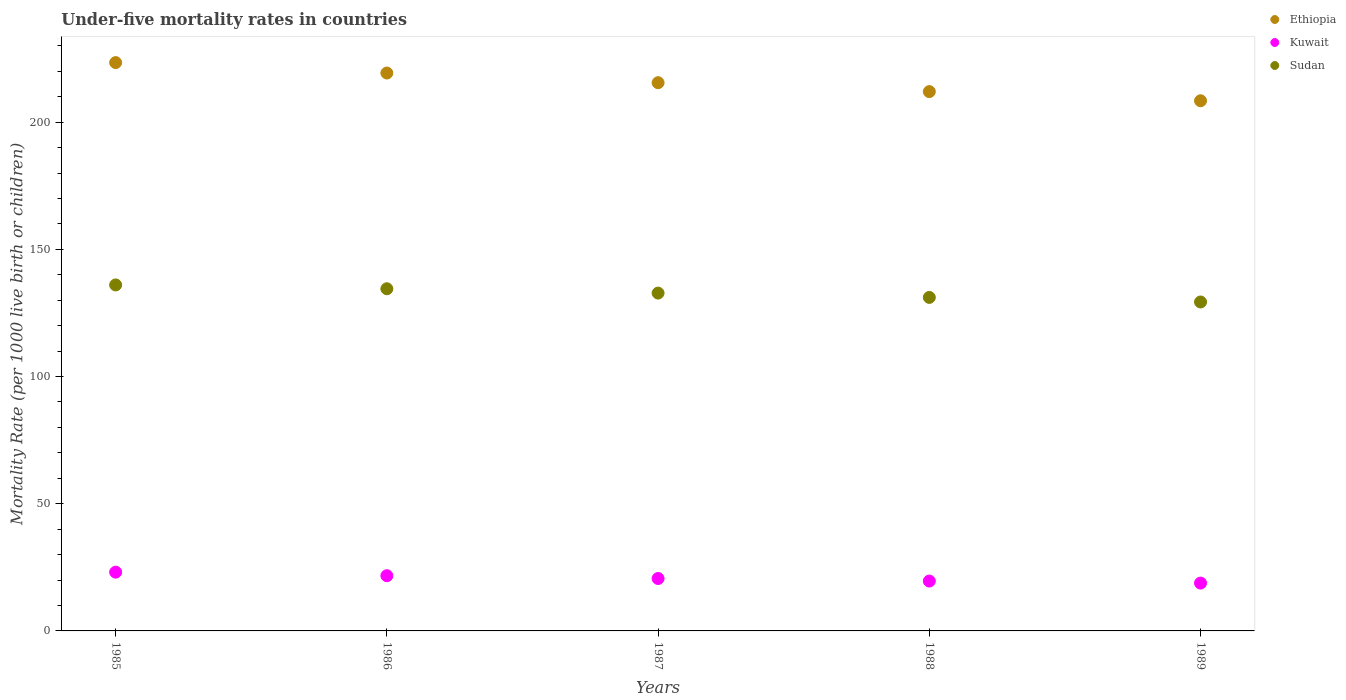Is the number of dotlines equal to the number of legend labels?
Give a very brief answer. Yes. What is the under-five mortality rate in Sudan in 1986?
Keep it short and to the point. 134.5. Across all years, what is the maximum under-five mortality rate in Sudan?
Offer a very short reply. 136. Across all years, what is the minimum under-five mortality rate in Sudan?
Your response must be concise. 129.3. What is the total under-five mortality rate in Kuwait in the graph?
Provide a succinct answer. 103.8. What is the difference between the under-five mortality rate in Ethiopia in 1985 and that in 1986?
Give a very brief answer. 4.1. What is the difference between the under-five mortality rate in Sudan in 1988 and the under-five mortality rate in Kuwait in 1989?
Provide a short and direct response. 112.3. What is the average under-five mortality rate in Kuwait per year?
Your answer should be very brief. 20.76. In the year 1985, what is the difference between the under-five mortality rate in Sudan and under-five mortality rate in Ethiopia?
Ensure brevity in your answer.  -87.4. In how many years, is the under-five mortality rate in Sudan greater than 50?
Give a very brief answer. 5. What is the ratio of the under-five mortality rate in Ethiopia in 1985 to that in 1986?
Your answer should be very brief. 1.02. What is the difference between the highest and the second highest under-five mortality rate in Kuwait?
Ensure brevity in your answer.  1.4. What is the difference between the highest and the lowest under-five mortality rate in Kuwait?
Provide a succinct answer. 4.3. Is it the case that in every year, the sum of the under-five mortality rate in Ethiopia and under-five mortality rate in Kuwait  is greater than the under-five mortality rate in Sudan?
Make the answer very short. Yes. How many years are there in the graph?
Make the answer very short. 5. What is the difference between two consecutive major ticks on the Y-axis?
Provide a succinct answer. 50. Does the graph contain any zero values?
Provide a short and direct response. No. How many legend labels are there?
Offer a terse response. 3. What is the title of the graph?
Give a very brief answer. Under-five mortality rates in countries. Does "Vietnam" appear as one of the legend labels in the graph?
Keep it short and to the point. No. What is the label or title of the X-axis?
Your response must be concise. Years. What is the label or title of the Y-axis?
Provide a short and direct response. Mortality Rate (per 1000 live birth or children). What is the Mortality Rate (per 1000 live birth or children) in Ethiopia in 1985?
Offer a very short reply. 223.4. What is the Mortality Rate (per 1000 live birth or children) of Kuwait in 1985?
Offer a very short reply. 23.1. What is the Mortality Rate (per 1000 live birth or children) in Sudan in 1985?
Your response must be concise. 136. What is the Mortality Rate (per 1000 live birth or children) in Ethiopia in 1986?
Offer a very short reply. 219.3. What is the Mortality Rate (per 1000 live birth or children) of Kuwait in 1986?
Your response must be concise. 21.7. What is the Mortality Rate (per 1000 live birth or children) in Sudan in 1986?
Provide a succinct answer. 134.5. What is the Mortality Rate (per 1000 live birth or children) of Ethiopia in 1987?
Your answer should be compact. 215.5. What is the Mortality Rate (per 1000 live birth or children) of Kuwait in 1987?
Your answer should be very brief. 20.6. What is the Mortality Rate (per 1000 live birth or children) of Sudan in 1987?
Provide a short and direct response. 132.8. What is the Mortality Rate (per 1000 live birth or children) in Ethiopia in 1988?
Provide a succinct answer. 212. What is the Mortality Rate (per 1000 live birth or children) in Kuwait in 1988?
Make the answer very short. 19.6. What is the Mortality Rate (per 1000 live birth or children) of Sudan in 1988?
Offer a very short reply. 131.1. What is the Mortality Rate (per 1000 live birth or children) of Ethiopia in 1989?
Your answer should be very brief. 208.4. What is the Mortality Rate (per 1000 live birth or children) of Sudan in 1989?
Give a very brief answer. 129.3. Across all years, what is the maximum Mortality Rate (per 1000 live birth or children) of Ethiopia?
Provide a short and direct response. 223.4. Across all years, what is the maximum Mortality Rate (per 1000 live birth or children) of Kuwait?
Make the answer very short. 23.1. Across all years, what is the maximum Mortality Rate (per 1000 live birth or children) in Sudan?
Offer a very short reply. 136. Across all years, what is the minimum Mortality Rate (per 1000 live birth or children) in Ethiopia?
Give a very brief answer. 208.4. Across all years, what is the minimum Mortality Rate (per 1000 live birth or children) in Sudan?
Provide a short and direct response. 129.3. What is the total Mortality Rate (per 1000 live birth or children) in Ethiopia in the graph?
Your answer should be very brief. 1078.6. What is the total Mortality Rate (per 1000 live birth or children) of Kuwait in the graph?
Offer a very short reply. 103.8. What is the total Mortality Rate (per 1000 live birth or children) of Sudan in the graph?
Your answer should be very brief. 663.7. What is the difference between the Mortality Rate (per 1000 live birth or children) of Ethiopia in 1985 and that in 1986?
Give a very brief answer. 4.1. What is the difference between the Mortality Rate (per 1000 live birth or children) of Kuwait in 1985 and that in 1986?
Give a very brief answer. 1.4. What is the difference between the Mortality Rate (per 1000 live birth or children) in Sudan in 1985 and that in 1986?
Offer a very short reply. 1.5. What is the difference between the Mortality Rate (per 1000 live birth or children) in Ethiopia in 1985 and that in 1987?
Ensure brevity in your answer.  7.9. What is the difference between the Mortality Rate (per 1000 live birth or children) of Sudan in 1985 and that in 1987?
Offer a very short reply. 3.2. What is the difference between the Mortality Rate (per 1000 live birth or children) in Ethiopia in 1985 and that in 1988?
Keep it short and to the point. 11.4. What is the difference between the Mortality Rate (per 1000 live birth or children) of Sudan in 1985 and that in 1988?
Provide a short and direct response. 4.9. What is the difference between the Mortality Rate (per 1000 live birth or children) of Kuwait in 1985 and that in 1989?
Provide a short and direct response. 4.3. What is the difference between the Mortality Rate (per 1000 live birth or children) of Kuwait in 1986 and that in 1987?
Ensure brevity in your answer.  1.1. What is the difference between the Mortality Rate (per 1000 live birth or children) of Sudan in 1986 and that in 1987?
Make the answer very short. 1.7. What is the difference between the Mortality Rate (per 1000 live birth or children) in Sudan in 1986 and that in 1988?
Ensure brevity in your answer.  3.4. What is the difference between the Mortality Rate (per 1000 live birth or children) of Ethiopia in 1986 and that in 1989?
Offer a terse response. 10.9. What is the difference between the Mortality Rate (per 1000 live birth or children) of Kuwait in 1986 and that in 1989?
Give a very brief answer. 2.9. What is the difference between the Mortality Rate (per 1000 live birth or children) of Kuwait in 1987 and that in 1988?
Provide a succinct answer. 1. What is the difference between the Mortality Rate (per 1000 live birth or children) in Ethiopia in 1987 and that in 1989?
Keep it short and to the point. 7.1. What is the difference between the Mortality Rate (per 1000 live birth or children) of Sudan in 1987 and that in 1989?
Your answer should be very brief. 3.5. What is the difference between the Mortality Rate (per 1000 live birth or children) in Ethiopia in 1988 and that in 1989?
Your response must be concise. 3.6. What is the difference between the Mortality Rate (per 1000 live birth or children) of Kuwait in 1988 and that in 1989?
Offer a terse response. 0.8. What is the difference between the Mortality Rate (per 1000 live birth or children) in Sudan in 1988 and that in 1989?
Give a very brief answer. 1.8. What is the difference between the Mortality Rate (per 1000 live birth or children) in Ethiopia in 1985 and the Mortality Rate (per 1000 live birth or children) in Kuwait in 1986?
Ensure brevity in your answer.  201.7. What is the difference between the Mortality Rate (per 1000 live birth or children) of Ethiopia in 1985 and the Mortality Rate (per 1000 live birth or children) of Sudan in 1986?
Ensure brevity in your answer.  88.9. What is the difference between the Mortality Rate (per 1000 live birth or children) in Kuwait in 1985 and the Mortality Rate (per 1000 live birth or children) in Sudan in 1986?
Provide a succinct answer. -111.4. What is the difference between the Mortality Rate (per 1000 live birth or children) in Ethiopia in 1985 and the Mortality Rate (per 1000 live birth or children) in Kuwait in 1987?
Ensure brevity in your answer.  202.8. What is the difference between the Mortality Rate (per 1000 live birth or children) of Ethiopia in 1985 and the Mortality Rate (per 1000 live birth or children) of Sudan in 1987?
Your answer should be compact. 90.6. What is the difference between the Mortality Rate (per 1000 live birth or children) in Kuwait in 1985 and the Mortality Rate (per 1000 live birth or children) in Sudan in 1987?
Keep it short and to the point. -109.7. What is the difference between the Mortality Rate (per 1000 live birth or children) of Ethiopia in 1985 and the Mortality Rate (per 1000 live birth or children) of Kuwait in 1988?
Make the answer very short. 203.8. What is the difference between the Mortality Rate (per 1000 live birth or children) of Ethiopia in 1985 and the Mortality Rate (per 1000 live birth or children) of Sudan in 1988?
Provide a short and direct response. 92.3. What is the difference between the Mortality Rate (per 1000 live birth or children) in Kuwait in 1985 and the Mortality Rate (per 1000 live birth or children) in Sudan in 1988?
Your response must be concise. -108. What is the difference between the Mortality Rate (per 1000 live birth or children) in Ethiopia in 1985 and the Mortality Rate (per 1000 live birth or children) in Kuwait in 1989?
Make the answer very short. 204.6. What is the difference between the Mortality Rate (per 1000 live birth or children) of Ethiopia in 1985 and the Mortality Rate (per 1000 live birth or children) of Sudan in 1989?
Ensure brevity in your answer.  94.1. What is the difference between the Mortality Rate (per 1000 live birth or children) in Kuwait in 1985 and the Mortality Rate (per 1000 live birth or children) in Sudan in 1989?
Make the answer very short. -106.2. What is the difference between the Mortality Rate (per 1000 live birth or children) of Ethiopia in 1986 and the Mortality Rate (per 1000 live birth or children) of Kuwait in 1987?
Make the answer very short. 198.7. What is the difference between the Mortality Rate (per 1000 live birth or children) in Ethiopia in 1986 and the Mortality Rate (per 1000 live birth or children) in Sudan in 1987?
Offer a very short reply. 86.5. What is the difference between the Mortality Rate (per 1000 live birth or children) in Kuwait in 1986 and the Mortality Rate (per 1000 live birth or children) in Sudan in 1987?
Your answer should be very brief. -111.1. What is the difference between the Mortality Rate (per 1000 live birth or children) of Ethiopia in 1986 and the Mortality Rate (per 1000 live birth or children) of Kuwait in 1988?
Keep it short and to the point. 199.7. What is the difference between the Mortality Rate (per 1000 live birth or children) of Ethiopia in 1986 and the Mortality Rate (per 1000 live birth or children) of Sudan in 1988?
Provide a short and direct response. 88.2. What is the difference between the Mortality Rate (per 1000 live birth or children) in Kuwait in 1986 and the Mortality Rate (per 1000 live birth or children) in Sudan in 1988?
Provide a short and direct response. -109.4. What is the difference between the Mortality Rate (per 1000 live birth or children) of Ethiopia in 1986 and the Mortality Rate (per 1000 live birth or children) of Kuwait in 1989?
Make the answer very short. 200.5. What is the difference between the Mortality Rate (per 1000 live birth or children) in Ethiopia in 1986 and the Mortality Rate (per 1000 live birth or children) in Sudan in 1989?
Your response must be concise. 90. What is the difference between the Mortality Rate (per 1000 live birth or children) of Kuwait in 1986 and the Mortality Rate (per 1000 live birth or children) of Sudan in 1989?
Your answer should be very brief. -107.6. What is the difference between the Mortality Rate (per 1000 live birth or children) in Ethiopia in 1987 and the Mortality Rate (per 1000 live birth or children) in Kuwait in 1988?
Your answer should be compact. 195.9. What is the difference between the Mortality Rate (per 1000 live birth or children) in Ethiopia in 1987 and the Mortality Rate (per 1000 live birth or children) in Sudan in 1988?
Offer a terse response. 84.4. What is the difference between the Mortality Rate (per 1000 live birth or children) in Kuwait in 1987 and the Mortality Rate (per 1000 live birth or children) in Sudan in 1988?
Ensure brevity in your answer.  -110.5. What is the difference between the Mortality Rate (per 1000 live birth or children) of Ethiopia in 1987 and the Mortality Rate (per 1000 live birth or children) of Kuwait in 1989?
Your answer should be compact. 196.7. What is the difference between the Mortality Rate (per 1000 live birth or children) in Ethiopia in 1987 and the Mortality Rate (per 1000 live birth or children) in Sudan in 1989?
Offer a very short reply. 86.2. What is the difference between the Mortality Rate (per 1000 live birth or children) of Kuwait in 1987 and the Mortality Rate (per 1000 live birth or children) of Sudan in 1989?
Offer a very short reply. -108.7. What is the difference between the Mortality Rate (per 1000 live birth or children) in Ethiopia in 1988 and the Mortality Rate (per 1000 live birth or children) in Kuwait in 1989?
Your answer should be very brief. 193.2. What is the difference between the Mortality Rate (per 1000 live birth or children) in Ethiopia in 1988 and the Mortality Rate (per 1000 live birth or children) in Sudan in 1989?
Your answer should be very brief. 82.7. What is the difference between the Mortality Rate (per 1000 live birth or children) in Kuwait in 1988 and the Mortality Rate (per 1000 live birth or children) in Sudan in 1989?
Provide a succinct answer. -109.7. What is the average Mortality Rate (per 1000 live birth or children) of Ethiopia per year?
Ensure brevity in your answer.  215.72. What is the average Mortality Rate (per 1000 live birth or children) of Kuwait per year?
Ensure brevity in your answer.  20.76. What is the average Mortality Rate (per 1000 live birth or children) in Sudan per year?
Ensure brevity in your answer.  132.74. In the year 1985, what is the difference between the Mortality Rate (per 1000 live birth or children) in Ethiopia and Mortality Rate (per 1000 live birth or children) in Kuwait?
Keep it short and to the point. 200.3. In the year 1985, what is the difference between the Mortality Rate (per 1000 live birth or children) in Ethiopia and Mortality Rate (per 1000 live birth or children) in Sudan?
Offer a terse response. 87.4. In the year 1985, what is the difference between the Mortality Rate (per 1000 live birth or children) of Kuwait and Mortality Rate (per 1000 live birth or children) of Sudan?
Offer a terse response. -112.9. In the year 1986, what is the difference between the Mortality Rate (per 1000 live birth or children) of Ethiopia and Mortality Rate (per 1000 live birth or children) of Kuwait?
Make the answer very short. 197.6. In the year 1986, what is the difference between the Mortality Rate (per 1000 live birth or children) of Ethiopia and Mortality Rate (per 1000 live birth or children) of Sudan?
Give a very brief answer. 84.8. In the year 1986, what is the difference between the Mortality Rate (per 1000 live birth or children) of Kuwait and Mortality Rate (per 1000 live birth or children) of Sudan?
Provide a succinct answer. -112.8. In the year 1987, what is the difference between the Mortality Rate (per 1000 live birth or children) of Ethiopia and Mortality Rate (per 1000 live birth or children) of Kuwait?
Offer a terse response. 194.9. In the year 1987, what is the difference between the Mortality Rate (per 1000 live birth or children) of Ethiopia and Mortality Rate (per 1000 live birth or children) of Sudan?
Provide a short and direct response. 82.7. In the year 1987, what is the difference between the Mortality Rate (per 1000 live birth or children) in Kuwait and Mortality Rate (per 1000 live birth or children) in Sudan?
Keep it short and to the point. -112.2. In the year 1988, what is the difference between the Mortality Rate (per 1000 live birth or children) of Ethiopia and Mortality Rate (per 1000 live birth or children) of Kuwait?
Give a very brief answer. 192.4. In the year 1988, what is the difference between the Mortality Rate (per 1000 live birth or children) in Ethiopia and Mortality Rate (per 1000 live birth or children) in Sudan?
Your answer should be very brief. 80.9. In the year 1988, what is the difference between the Mortality Rate (per 1000 live birth or children) of Kuwait and Mortality Rate (per 1000 live birth or children) of Sudan?
Offer a very short reply. -111.5. In the year 1989, what is the difference between the Mortality Rate (per 1000 live birth or children) in Ethiopia and Mortality Rate (per 1000 live birth or children) in Kuwait?
Make the answer very short. 189.6. In the year 1989, what is the difference between the Mortality Rate (per 1000 live birth or children) in Ethiopia and Mortality Rate (per 1000 live birth or children) in Sudan?
Provide a short and direct response. 79.1. In the year 1989, what is the difference between the Mortality Rate (per 1000 live birth or children) in Kuwait and Mortality Rate (per 1000 live birth or children) in Sudan?
Offer a very short reply. -110.5. What is the ratio of the Mortality Rate (per 1000 live birth or children) in Ethiopia in 1985 to that in 1986?
Offer a very short reply. 1.02. What is the ratio of the Mortality Rate (per 1000 live birth or children) of Kuwait in 1985 to that in 1986?
Make the answer very short. 1.06. What is the ratio of the Mortality Rate (per 1000 live birth or children) in Sudan in 1985 to that in 1986?
Make the answer very short. 1.01. What is the ratio of the Mortality Rate (per 1000 live birth or children) in Ethiopia in 1985 to that in 1987?
Offer a very short reply. 1.04. What is the ratio of the Mortality Rate (per 1000 live birth or children) in Kuwait in 1985 to that in 1987?
Make the answer very short. 1.12. What is the ratio of the Mortality Rate (per 1000 live birth or children) in Sudan in 1985 to that in 1987?
Offer a terse response. 1.02. What is the ratio of the Mortality Rate (per 1000 live birth or children) of Ethiopia in 1985 to that in 1988?
Give a very brief answer. 1.05. What is the ratio of the Mortality Rate (per 1000 live birth or children) in Kuwait in 1985 to that in 1988?
Offer a terse response. 1.18. What is the ratio of the Mortality Rate (per 1000 live birth or children) in Sudan in 1985 to that in 1988?
Give a very brief answer. 1.04. What is the ratio of the Mortality Rate (per 1000 live birth or children) in Ethiopia in 1985 to that in 1989?
Give a very brief answer. 1.07. What is the ratio of the Mortality Rate (per 1000 live birth or children) of Kuwait in 1985 to that in 1989?
Offer a very short reply. 1.23. What is the ratio of the Mortality Rate (per 1000 live birth or children) of Sudan in 1985 to that in 1989?
Give a very brief answer. 1.05. What is the ratio of the Mortality Rate (per 1000 live birth or children) of Ethiopia in 1986 to that in 1987?
Your answer should be very brief. 1.02. What is the ratio of the Mortality Rate (per 1000 live birth or children) in Kuwait in 1986 to that in 1987?
Your response must be concise. 1.05. What is the ratio of the Mortality Rate (per 1000 live birth or children) in Sudan in 1986 to that in 1987?
Offer a terse response. 1.01. What is the ratio of the Mortality Rate (per 1000 live birth or children) in Ethiopia in 1986 to that in 1988?
Offer a terse response. 1.03. What is the ratio of the Mortality Rate (per 1000 live birth or children) of Kuwait in 1986 to that in 1988?
Your answer should be very brief. 1.11. What is the ratio of the Mortality Rate (per 1000 live birth or children) of Sudan in 1986 to that in 1988?
Offer a terse response. 1.03. What is the ratio of the Mortality Rate (per 1000 live birth or children) in Ethiopia in 1986 to that in 1989?
Make the answer very short. 1.05. What is the ratio of the Mortality Rate (per 1000 live birth or children) of Kuwait in 1986 to that in 1989?
Your response must be concise. 1.15. What is the ratio of the Mortality Rate (per 1000 live birth or children) of Sudan in 1986 to that in 1989?
Offer a terse response. 1.04. What is the ratio of the Mortality Rate (per 1000 live birth or children) in Ethiopia in 1987 to that in 1988?
Your response must be concise. 1.02. What is the ratio of the Mortality Rate (per 1000 live birth or children) in Kuwait in 1987 to that in 1988?
Your answer should be very brief. 1.05. What is the ratio of the Mortality Rate (per 1000 live birth or children) of Sudan in 1987 to that in 1988?
Offer a terse response. 1.01. What is the ratio of the Mortality Rate (per 1000 live birth or children) of Ethiopia in 1987 to that in 1989?
Ensure brevity in your answer.  1.03. What is the ratio of the Mortality Rate (per 1000 live birth or children) in Kuwait in 1987 to that in 1989?
Offer a terse response. 1.1. What is the ratio of the Mortality Rate (per 1000 live birth or children) in Sudan in 1987 to that in 1989?
Provide a succinct answer. 1.03. What is the ratio of the Mortality Rate (per 1000 live birth or children) in Ethiopia in 1988 to that in 1989?
Provide a succinct answer. 1.02. What is the ratio of the Mortality Rate (per 1000 live birth or children) of Kuwait in 1988 to that in 1989?
Your answer should be compact. 1.04. What is the ratio of the Mortality Rate (per 1000 live birth or children) in Sudan in 1988 to that in 1989?
Your response must be concise. 1.01. What is the difference between the highest and the lowest Mortality Rate (per 1000 live birth or children) in Ethiopia?
Your answer should be compact. 15. 